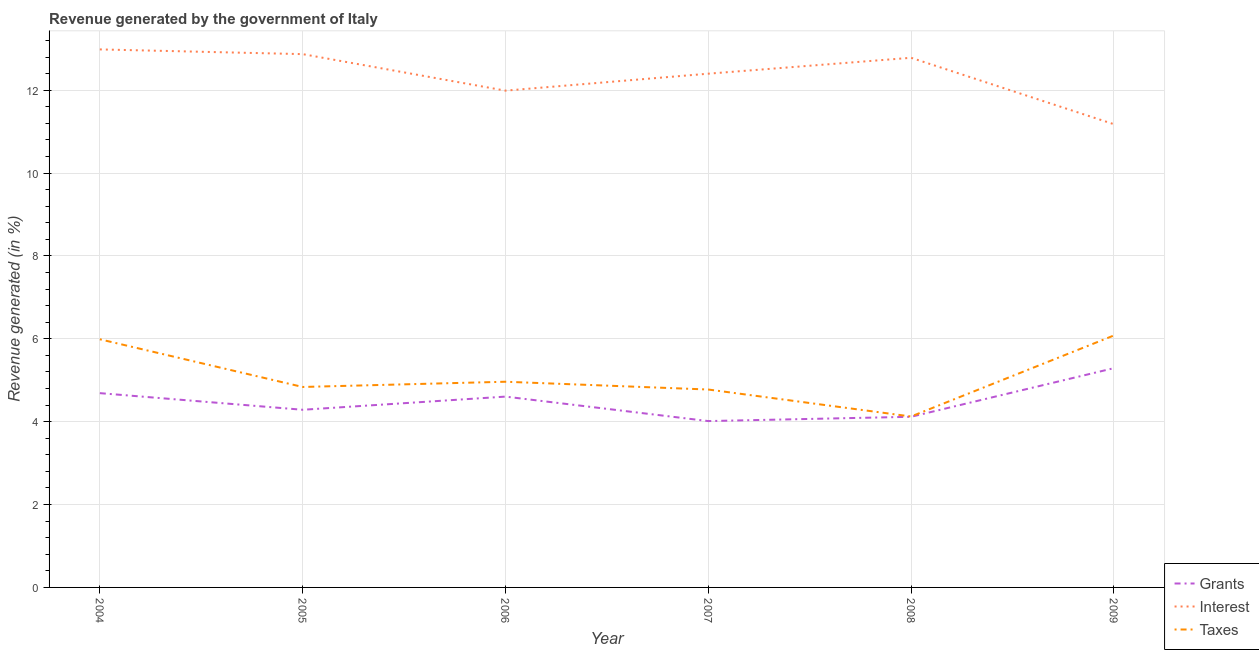How many different coloured lines are there?
Ensure brevity in your answer.  3. Does the line corresponding to percentage of revenue generated by taxes intersect with the line corresponding to percentage of revenue generated by interest?
Offer a terse response. No. What is the percentage of revenue generated by interest in 2009?
Your answer should be compact. 11.18. Across all years, what is the maximum percentage of revenue generated by taxes?
Offer a terse response. 6.08. Across all years, what is the minimum percentage of revenue generated by grants?
Give a very brief answer. 4.01. In which year was the percentage of revenue generated by grants minimum?
Your response must be concise. 2007. What is the total percentage of revenue generated by taxes in the graph?
Your answer should be very brief. 30.77. What is the difference between the percentage of revenue generated by interest in 2005 and that in 2009?
Provide a short and direct response. 1.69. What is the difference between the percentage of revenue generated by taxes in 2006 and the percentage of revenue generated by grants in 2009?
Give a very brief answer. -0.33. What is the average percentage of revenue generated by interest per year?
Provide a succinct answer. 12.37. In the year 2007, what is the difference between the percentage of revenue generated by taxes and percentage of revenue generated by interest?
Your answer should be compact. -7.62. What is the ratio of the percentage of revenue generated by taxes in 2006 to that in 2008?
Provide a succinct answer. 1.2. Is the percentage of revenue generated by interest in 2008 less than that in 2009?
Your response must be concise. No. What is the difference between the highest and the second highest percentage of revenue generated by interest?
Provide a succinct answer. 0.11. What is the difference between the highest and the lowest percentage of revenue generated by taxes?
Give a very brief answer. 1.96. Is the sum of the percentage of revenue generated by interest in 2008 and 2009 greater than the maximum percentage of revenue generated by grants across all years?
Provide a short and direct response. Yes. Is it the case that in every year, the sum of the percentage of revenue generated by grants and percentage of revenue generated by interest is greater than the percentage of revenue generated by taxes?
Your answer should be very brief. Yes. Is the percentage of revenue generated by taxes strictly greater than the percentage of revenue generated by interest over the years?
Provide a succinct answer. No. Is the percentage of revenue generated by grants strictly less than the percentage of revenue generated by interest over the years?
Offer a very short reply. Yes. How many years are there in the graph?
Provide a succinct answer. 6. What is the difference between two consecutive major ticks on the Y-axis?
Keep it short and to the point. 2. Does the graph contain grids?
Provide a short and direct response. Yes. Where does the legend appear in the graph?
Give a very brief answer. Bottom right. How many legend labels are there?
Keep it short and to the point. 3. What is the title of the graph?
Your answer should be compact. Revenue generated by the government of Italy. Does "Other sectors" appear as one of the legend labels in the graph?
Offer a terse response. No. What is the label or title of the X-axis?
Ensure brevity in your answer.  Year. What is the label or title of the Y-axis?
Offer a very short reply. Revenue generated (in %). What is the Revenue generated (in %) of Grants in 2004?
Make the answer very short. 4.69. What is the Revenue generated (in %) in Interest in 2004?
Offer a terse response. 12.99. What is the Revenue generated (in %) in Taxes in 2004?
Offer a terse response. 5.99. What is the Revenue generated (in %) of Grants in 2005?
Provide a short and direct response. 4.29. What is the Revenue generated (in %) of Interest in 2005?
Provide a short and direct response. 12.87. What is the Revenue generated (in %) in Taxes in 2005?
Give a very brief answer. 4.84. What is the Revenue generated (in %) in Grants in 2006?
Provide a succinct answer. 4.61. What is the Revenue generated (in %) of Interest in 2006?
Give a very brief answer. 11.99. What is the Revenue generated (in %) of Taxes in 2006?
Your answer should be compact. 4.96. What is the Revenue generated (in %) in Grants in 2007?
Provide a succinct answer. 4.01. What is the Revenue generated (in %) of Interest in 2007?
Provide a short and direct response. 12.4. What is the Revenue generated (in %) of Taxes in 2007?
Provide a short and direct response. 4.78. What is the Revenue generated (in %) of Grants in 2008?
Provide a succinct answer. 4.12. What is the Revenue generated (in %) of Interest in 2008?
Ensure brevity in your answer.  12.78. What is the Revenue generated (in %) of Taxes in 2008?
Give a very brief answer. 4.13. What is the Revenue generated (in %) of Grants in 2009?
Your answer should be very brief. 5.29. What is the Revenue generated (in %) of Interest in 2009?
Ensure brevity in your answer.  11.18. What is the Revenue generated (in %) of Taxes in 2009?
Your answer should be compact. 6.08. Across all years, what is the maximum Revenue generated (in %) in Grants?
Your answer should be compact. 5.29. Across all years, what is the maximum Revenue generated (in %) of Interest?
Provide a short and direct response. 12.99. Across all years, what is the maximum Revenue generated (in %) in Taxes?
Offer a terse response. 6.08. Across all years, what is the minimum Revenue generated (in %) in Grants?
Make the answer very short. 4.01. Across all years, what is the minimum Revenue generated (in %) of Interest?
Give a very brief answer. 11.18. Across all years, what is the minimum Revenue generated (in %) of Taxes?
Offer a very short reply. 4.13. What is the total Revenue generated (in %) of Grants in the graph?
Provide a short and direct response. 27.01. What is the total Revenue generated (in %) in Interest in the graph?
Your answer should be compact. 74.21. What is the total Revenue generated (in %) in Taxes in the graph?
Offer a terse response. 30.77. What is the difference between the Revenue generated (in %) in Grants in 2004 and that in 2005?
Ensure brevity in your answer.  0.4. What is the difference between the Revenue generated (in %) of Interest in 2004 and that in 2005?
Keep it short and to the point. 0.11. What is the difference between the Revenue generated (in %) in Taxes in 2004 and that in 2005?
Make the answer very short. 1.15. What is the difference between the Revenue generated (in %) in Grants in 2004 and that in 2006?
Your response must be concise. 0.08. What is the difference between the Revenue generated (in %) of Interest in 2004 and that in 2006?
Give a very brief answer. 1. What is the difference between the Revenue generated (in %) in Taxes in 2004 and that in 2006?
Give a very brief answer. 1.02. What is the difference between the Revenue generated (in %) of Grants in 2004 and that in 2007?
Offer a very short reply. 0.67. What is the difference between the Revenue generated (in %) of Interest in 2004 and that in 2007?
Make the answer very short. 0.59. What is the difference between the Revenue generated (in %) of Taxes in 2004 and that in 2007?
Offer a terse response. 1.21. What is the difference between the Revenue generated (in %) of Grants in 2004 and that in 2008?
Your answer should be compact. 0.57. What is the difference between the Revenue generated (in %) of Interest in 2004 and that in 2008?
Provide a short and direct response. 0.2. What is the difference between the Revenue generated (in %) in Taxes in 2004 and that in 2008?
Give a very brief answer. 1.86. What is the difference between the Revenue generated (in %) in Grants in 2004 and that in 2009?
Offer a very short reply. -0.6. What is the difference between the Revenue generated (in %) in Interest in 2004 and that in 2009?
Offer a very short reply. 1.8. What is the difference between the Revenue generated (in %) in Taxes in 2004 and that in 2009?
Make the answer very short. -0.09. What is the difference between the Revenue generated (in %) in Grants in 2005 and that in 2006?
Your answer should be very brief. -0.32. What is the difference between the Revenue generated (in %) in Interest in 2005 and that in 2006?
Your answer should be very brief. 0.88. What is the difference between the Revenue generated (in %) of Taxes in 2005 and that in 2006?
Provide a succinct answer. -0.13. What is the difference between the Revenue generated (in %) of Grants in 2005 and that in 2007?
Provide a succinct answer. 0.27. What is the difference between the Revenue generated (in %) in Interest in 2005 and that in 2007?
Keep it short and to the point. 0.47. What is the difference between the Revenue generated (in %) of Taxes in 2005 and that in 2007?
Offer a terse response. 0.06. What is the difference between the Revenue generated (in %) of Grants in 2005 and that in 2008?
Provide a succinct answer. 0.17. What is the difference between the Revenue generated (in %) in Interest in 2005 and that in 2008?
Provide a succinct answer. 0.09. What is the difference between the Revenue generated (in %) in Taxes in 2005 and that in 2008?
Your answer should be very brief. 0.71. What is the difference between the Revenue generated (in %) in Grants in 2005 and that in 2009?
Give a very brief answer. -1. What is the difference between the Revenue generated (in %) in Interest in 2005 and that in 2009?
Your answer should be very brief. 1.69. What is the difference between the Revenue generated (in %) in Taxes in 2005 and that in 2009?
Keep it short and to the point. -1.24. What is the difference between the Revenue generated (in %) in Grants in 2006 and that in 2007?
Your answer should be compact. 0.59. What is the difference between the Revenue generated (in %) of Interest in 2006 and that in 2007?
Your answer should be very brief. -0.41. What is the difference between the Revenue generated (in %) of Taxes in 2006 and that in 2007?
Provide a succinct answer. 0.19. What is the difference between the Revenue generated (in %) in Grants in 2006 and that in 2008?
Provide a succinct answer. 0.49. What is the difference between the Revenue generated (in %) in Interest in 2006 and that in 2008?
Your answer should be compact. -0.79. What is the difference between the Revenue generated (in %) of Taxes in 2006 and that in 2008?
Make the answer very short. 0.84. What is the difference between the Revenue generated (in %) in Grants in 2006 and that in 2009?
Your response must be concise. -0.69. What is the difference between the Revenue generated (in %) in Interest in 2006 and that in 2009?
Your answer should be compact. 0.81. What is the difference between the Revenue generated (in %) in Taxes in 2006 and that in 2009?
Your response must be concise. -1.12. What is the difference between the Revenue generated (in %) in Grants in 2007 and that in 2008?
Offer a terse response. -0.1. What is the difference between the Revenue generated (in %) of Interest in 2007 and that in 2008?
Give a very brief answer. -0.38. What is the difference between the Revenue generated (in %) of Taxes in 2007 and that in 2008?
Provide a short and direct response. 0.65. What is the difference between the Revenue generated (in %) of Grants in 2007 and that in 2009?
Offer a very short reply. -1.28. What is the difference between the Revenue generated (in %) in Interest in 2007 and that in 2009?
Your answer should be compact. 1.22. What is the difference between the Revenue generated (in %) of Taxes in 2007 and that in 2009?
Your response must be concise. -1.3. What is the difference between the Revenue generated (in %) in Grants in 2008 and that in 2009?
Make the answer very short. -1.17. What is the difference between the Revenue generated (in %) of Interest in 2008 and that in 2009?
Offer a terse response. 1.6. What is the difference between the Revenue generated (in %) of Taxes in 2008 and that in 2009?
Provide a short and direct response. -1.96. What is the difference between the Revenue generated (in %) in Grants in 2004 and the Revenue generated (in %) in Interest in 2005?
Your response must be concise. -8.18. What is the difference between the Revenue generated (in %) of Grants in 2004 and the Revenue generated (in %) of Taxes in 2005?
Provide a short and direct response. -0.15. What is the difference between the Revenue generated (in %) in Interest in 2004 and the Revenue generated (in %) in Taxes in 2005?
Keep it short and to the point. 8.15. What is the difference between the Revenue generated (in %) of Grants in 2004 and the Revenue generated (in %) of Interest in 2006?
Your answer should be very brief. -7.3. What is the difference between the Revenue generated (in %) in Grants in 2004 and the Revenue generated (in %) in Taxes in 2006?
Ensure brevity in your answer.  -0.28. What is the difference between the Revenue generated (in %) of Interest in 2004 and the Revenue generated (in %) of Taxes in 2006?
Provide a succinct answer. 8.02. What is the difference between the Revenue generated (in %) of Grants in 2004 and the Revenue generated (in %) of Interest in 2007?
Ensure brevity in your answer.  -7.71. What is the difference between the Revenue generated (in %) in Grants in 2004 and the Revenue generated (in %) in Taxes in 2007?
Provide a succinct answer. -0.09. What is the difference between the Revenue generated (in %) of Interest in 2004 and the Revenue generated (in %) of Taxes in 2007?
Provide a short and direct response. 8.21. What is the difference between the Revenue generated (in %) of Grants in 2004 and the Revenue generated (in %) of Interest in 2008?
Offer a very short reply. -8.09. What is the difference between the Revenue generated (in %) of Grants in 2004 and the Revenue generated (in %) of Taxes in 2008?
Your response must be concise. 0.56. What is the difference between the Revenue generated (in %) of Interest in 2004 and the Revenue generated (in %) of Taxes in 2008?
Provide a short and direct response. 8.86. What is the difference between the Revenue generated (in %) in Grants in 2004 and the Revenue generated (in %) in Interest in 2009?
Provide a succinct answer. -6.49. What is the difference between the Revenue generated (in %) in Grants in 2004 and the Revenue generated (in %) in Taxes in 2009?
Your answer should be compact. -1.39. What is the difference between the Revenue generated (in %) in Interest in 2004 and the Revenue generated (in %) in Taxes in 2009?
Provide a succinct answer. 6.9. What is the difference between the Revenue generated (in %) in Grants in 2005 and the Revenue generated (in %) in Interest in 2006?
Make the answer very short. -7.7. What is the difference between the Revenue generated (in %) in Grants in 2005 and the Revenue generated (in %) in Taxes in 2006?
Your answer should be very brief. -0.68. What is the difference between the Revenue generated (in %) of Interest in 2005 and the Revenue generated (in %) of Taxes in 2006?
Ensure brevity in your answer.  7.91. What is the difference between the Revenue generated (in %) in Grants in 2005 and the Revenue generated (in %) in Interest in 2007?
Provide a succinct answer. -8.11. What is the difference between the Revenue generated (in %) in Grants in 2005 and the Revenue generated (in %) in Taxes in 2007?
Give a very brief answer. -0.49. What is the difference between the Revenue generated (in %) in Interest in 2005 and the Revenue generated (in %) in Taxes in 2007?
Provide a succinct answer. 8.09. What is the difference between the Revenue generated (in %) in Grants in 2005 and the Revenue generated (in %) in Interest in 2008?
Your answer should be compact. -8.5. What is the difference between the Revenue generated (in %) of Grants in 2005 and the Revenue generated (in %) of Taxes in 2008?
Make the answer very short. 0.16. What is the difference between the Revenue generated (in %) in Interest in 2005 and the Revenue generated (in %) in Taxes in 2008?
Give a very brief answer. 8.75. What is the difference between the Revenue generated (in %) of Grants in 2005 and the Revenue generated (in %) of Interest in 2009?
Offer a terse response. -6.89. What is the difference between the Revenue generated (in %) in Grants in 2005 and the Revenue generated (in %) in Taxes in 2009?
Make the answer very short. -1.79. What is the difference between the Revenue generated (in %) in Interest in 2005 and the Revenue generated (in %) in Taxes in 2009?
Keep it short and to the point. 6.79. What is the difference between the Revenue generated (in %) in Grants in 2006 and the Revenue generated (in %) in Interest in 2007?
Your response must be concise. -7.79. What is the difference between the Revenue generated (in %) of Grants in 2006 and the Revenue generated (in %) of Taxes in 2007?
Your answer should be compact. -0.17. What is the difference between the Revenue generated (in %) of Interest in 2006 and the Revenue generated (in %) of Taxes in 2007?
Make the answer very short. 7.21. What is the difference between the Revenue generated (in %) in Grants in 2006 and the Revenue generated (in %) in Interest in 2008?
Your answer should be very brief. -8.18. What is the difference between the Revenue generated (in %) in Grants in 2006 and the Revenue generated (in %) in Taxes in 2008?
Make the answer very short. 0.48. What is the difference between the Revenue generated (in %) of Interest in 2006 and the Revenue generated (in %) of Taxes in 2008?
Provide a succinct answer. 7.86. What is the difference between the Revenue generated (in %) of Grants in 2006 and the Revenue generated (in %) of Interest in 2009?
Make the answer very short. -6.57. What is the difference between the Revenue generated (in %) in Grants in 2006 and the Revenue generated (in %) in Taxes in 2009?
Offer a very short reply. -1.48. What is the difference between the Revenue generated (in %) in Interest in 2006 and the Revenue generated (in %) in Taxes in 2009?
Your answer should be compact. 5.91. What is the difference between the Revenue generated (in %) in Grants in 2007 and the Revenue generated (in %) in Interest in 2008?
Offer a very short reply. -8.77. What is the difference between the Revenue generated (in %) in Grants in 2007 and the Revenue generated (in %) in Taxes in 2008?
Keep it short and to the point. -0.11. What is the difference between the Revenue generated (in %) of Interest in 2007 and the Revenue generated (in %) of Taxes in 2008?
Offer a terse response. 8.27. What is the difference between the Revenue generated (in %) in Grants in 2007 and the Revenue generated (in %) in Interest in 2009?
Offer a terse response. -7.17. What is the difference between the Revenue generated (in %) of Grants in 2007 and the Revenue generated (in %) of Taxes in 2009?
Provide a short and direct response. -2.07. What is the difference between the Revenue generated (in %) in Interest in 2007 and the Revenue generated (in %) in Taxes in 2009?
Ensure brevity in your answer.  6.32. What is the difference between the Revenue generated (in %) in Grants in 2008 and the Revenue generated (in %) in Interest in 2009?
Your response must be concise. -7.06. What is the difference between the Revenue generated (in %) in Grants in 2008 and the Revenue generated (in %) in Taxes in 2009?
Provide a short and direct response. -1.96. What is the difference between the Revenue generated (in %) in Interest in 2008 and the Revenue generated (in %) in Taxes in 2009?
Offer a terse response. 6.7. What is the average Revenue generated (in %) in Grants per year?
Ensure brevity in your answer.  4.5. What is the average Revenue generated (in %) in Interest per year?
Offer a terse response. 12.37. What is the average Revenue generated (in %) of Taxes per year?
Your response must be concise. 5.13. In the year 2004, what is the difference between the Revenue generated (in %) in Grants and Revenue generated (in %) in Interest?
Keep it short and to the point. -8.3. In the year 2004, what is the difference between the Revenue generated (in %) of Grants and Revenue generated (in %) of Taxes?
Offer a terse response. -1.3. In the year 2004, what is the difference between the Revenue generated (in %) of Interest and Revenue generated (in %) of Taxes?
Offer a very short reply. 7. In the year 2005, what is the difference between the Revenue generated (in %) of Grants and Revenue generated (in %) of Interest?
Make the answer very short. -8.58. In the year 2005, what is the difference between the Revenue generated (in %) of Grants and Revenue generated (in %) of Taxes?
Offer a terse response. -0.55. In the year 2005, what is the difference between the Revenue generated (in %) in Interest and Revenue generated (in %) in Taxes?
Ensure brevity in your answer.  8.03. In the year 2006, what is the difference between the Revenue generated (in %) in Grants and Revenue generated (in %) in Interest?
Ensure brevity in your answer.  -7.38. In the year 2006, what is the difference between the Revenue generated (in %) in Grants and Revenue generated (in %) in Taxes?
Ensure brevity in your answer.  -0.36. In the year 2006, what is the difference between the Revenue generated (in %) of Interest and Revenue generated (in %) of Taxes?
Your answer should be compact. 7.03. In the year 2007, what is the difference between the Revenue generated (in %) in Grants and Revenue generated (in %) in Interest?
Ensure brevity in your answer.  -8.38. In the year 2007, what is the difference between the Revenue generated (in %) of Grants and Revenue generated (in %) of Taxes?
Offer a terse response. -0.76. In the year 2007, what is the difference between the Revenue generated (in %) of Interest and Revenue generated (in %) of Taxes?
Your response must be concise. 7.62. In the year 2008, what is the difference between the Revenue generated (in %) in Grants and Revenue generated (in %) in Interest?
Ensure brevity in your answer.  -8.66. In the year 2008, what is the difference between the Revenue generated (in %) of Grants and Revenue generated (in %) of Taxes?
Your answer should be very brief. -0.01. In the year 2008, what is the difference between the Revenue generated (in %) in Interest and Revenue generated (in %) in Taxes?
Provide a short and direct response. 8.66. In the year 2009, what is the difference between the Revenue generated (in %) in Grants and Revenue generated (in %) in Interest?
Provide a succinct answer. -5.89. In the year 2009, what is the difference between the Revenue generated (in %) of Grants and Revenue generated (in %) of Taxes?
Your answer should be very brief. -0.79. In the year 2009, what is the difference between the Revenue generated (in %) in Interest and Revenue generated (in %) in Taxes?
Your answer should be very brief. 5.1. What is the ratio of the Revenue generated (in %) in Grants in 2004 to that in 2005?
Offer a terse response. 1.09. What is the ratio of the Revenue generated (in %) of Interest in 2004 to that in 2005?
Offer a terse response. 1.01. What is the ratio of the Revenue generated (in %) of Taxes in 2004 to that in 2005?
Ensure brevity in your answer.  1.24. What is the ratio of the Revenue generated (in %) of Grants in 2004 to that in 2006?
Offer a very short reply. 1.02. What is the ratio of the Revenue generated (in %) in Interest in 2004 to that in 2006?
Provide a short and direct response. 1.08. What is the ratio of the Revenue generated (in %) in Taxes in 2004 to that in 2006?
Keep it short and to the point. 1.21. What is the ratio of the Revenue generated (in %) of Grants in 2004 to that in 2007?
Your answer should be very brief. 1.17. What is the ratio of the Revenue generated (in %) of Interest in 2004 to that in 2007?
Your answer should be compact. 1.05. What is the ratio of the Revenue generated (in %) of Taxes in 2004 to that in 2007?
Keep it short and to the point. 1.25. What is the ratio of the Revenue generated (in %) of Grants in 2004 to that in 2008?
Keep it short and to the point. 1.14. What is the ratio of the Revenue generated (in %) of Interest in 2004 to that in 2008?
Ensure brevity in your answer.  1.02. What is the ratio of the Revenue generated (in %) in Taxes in 2004 to that in 2008?
Make the answer very short. 1.45. What is the ratio of the Revenue generated (in %) in Grants in 2004 to that in 2009?
Keep it short and to the point. 0.89. What is the ratio of the Revenue generated (in %) in Interest in 2004 to that in 2009?
Offer a terse response. 1.16. What is the ratio of the Revenue generated (in %) of Taxes in 2004 to that in 2009?
Your answer should be compact. 0.98. What is the ratio of the Revenue generated (in %) in Interest in 2005 to that in 2006?
Ensure brevity in your answer.  1.07. What is the ratio of the Revenue generated (in %) of Taxes in 2005 to that in 2006?
Your answer should be very brief. 0.97. What is the ratio of the Revenue generated (in %) of Grants in 2005 to that in 2007?
Provide a short and direct response. 1.07. What is the ratio of the Revenue generated (in %) in Interest in 2005 to that in 2007?
Provide a short and direct response. 1.04. What is the ratio of the Revenue generated (in %) of Taxes in 2005 to that in 2007?
Ensure brevity in your answer.  1.01. What is the ratio of the Revenue generated (in %) of Grants in 2005 to that in 2008?
Provide a succinct answer. 1.04. What is the ratio of the Revenue generated (in %) of Taxes in 2005 to that in 2008?
Ensure brevity in your answer.  1.17. What is the ratio of the Revenue generated (in %) in Grants in 2005 to that in 2009?
Your response must be concise. 0.81. What is the ratio of the Revenue generated (in %) of Interest in 2005 to that in 2009?
Your response must be concise. 1.15. What is the ratio of the Revenue generated (in %) of Taxes in 2005 to that in 2009?
Offer a terse response. 0.8. What is the ratio of the Revenue generated (in %) in Grants in 2006 to that in 2007?
Your answer should be very brief. 1.15. What is the ratio of the Revenue generated (in %) in Taxes in 2006 to that in 2007?
Make the answer very short. 1.04. What is the ratio of the Revenue generated (in %) of Grants in 2006 to that in 2008?
Keep it short and to the point. 1.12. What is the ratio of the Revenue generated (in %) of Interest in 2006 to that in 2008?
Provide a succinct answer. 0.94. What is the ratio of the Revenue generated (in %) in Taxes in 2006 to that in 2008?
Provide a short and direct response. 1.2. What is the ratio of the Revenue generated (in %) of Grants in 2006 to that in 2009?
Your answer should be very brief. 0.87. What is the ratio of the Revenue generated (in %) in Interest in 2006 to that in 2009?
Offer a very short reply. 1.07. What is the ratio of the Revenue generated (in %) of Taxes in 2006 to that in 2009?
Keep it short and to the point. 0.82. What is the ratio of the Revenue generated (in %) in Grants in 2007 to that in 2008?
Your answer should be very brief. 0.97. What is the ratio of the Revenue generated (in %) of Taxes in 2007 to that in 2008?
Provide a succinct answer. 1.16. What is the ratio of the Revenue generated (in %) in Grants in 2007 to that in 2009?
Offer a very short reply. 0.76. What is the ratio of the Revenue generated (in %) of Interest in 2007 to that in 2009?
Your answer should be very brief. 1.11. What is the ratio of the Revenue generated (in %) of Taxes in 2007 to that in 2009?
Give a very brief answer. 0.79. What is the ratio of the Revenue generated (in %) in Grants in 2008 to that in 2009?
Your response must be concise. 0.78. What is the ratio of the Revenue generated (in %) of Interest in 2008 to that in 2009?
Give a very brief answer. 1.14. What is the ratio of the Revenue generated (in %) of Taxes in 2008 to that in 2009?
Make the answer very short. 0.68. What is the difference between the highest and the second highest Revenue generated (in %) in Grants?
Your answer should be compact. 0.6. What is the difference between the highest and the second highest Revenue generated (in %) in Interest?
Your response must be concise. 0.11. What is the difference between the highest and the second highest Revenue generated (in %) in Taxes?
Your response must be concise. 0.09. What is the difference between the highest and the lowest Revenue generated (in %) in Grants?
Keep it short and to the point. 1.28. What is the difference between the highest and the lowest Revenue generated (in %) in Interest?
Give a very brief answer. 1.8. What is the difference between the highest and the lowest Revenue generated (in %) in Taxes?
Your answer should be compact. 1.96. 